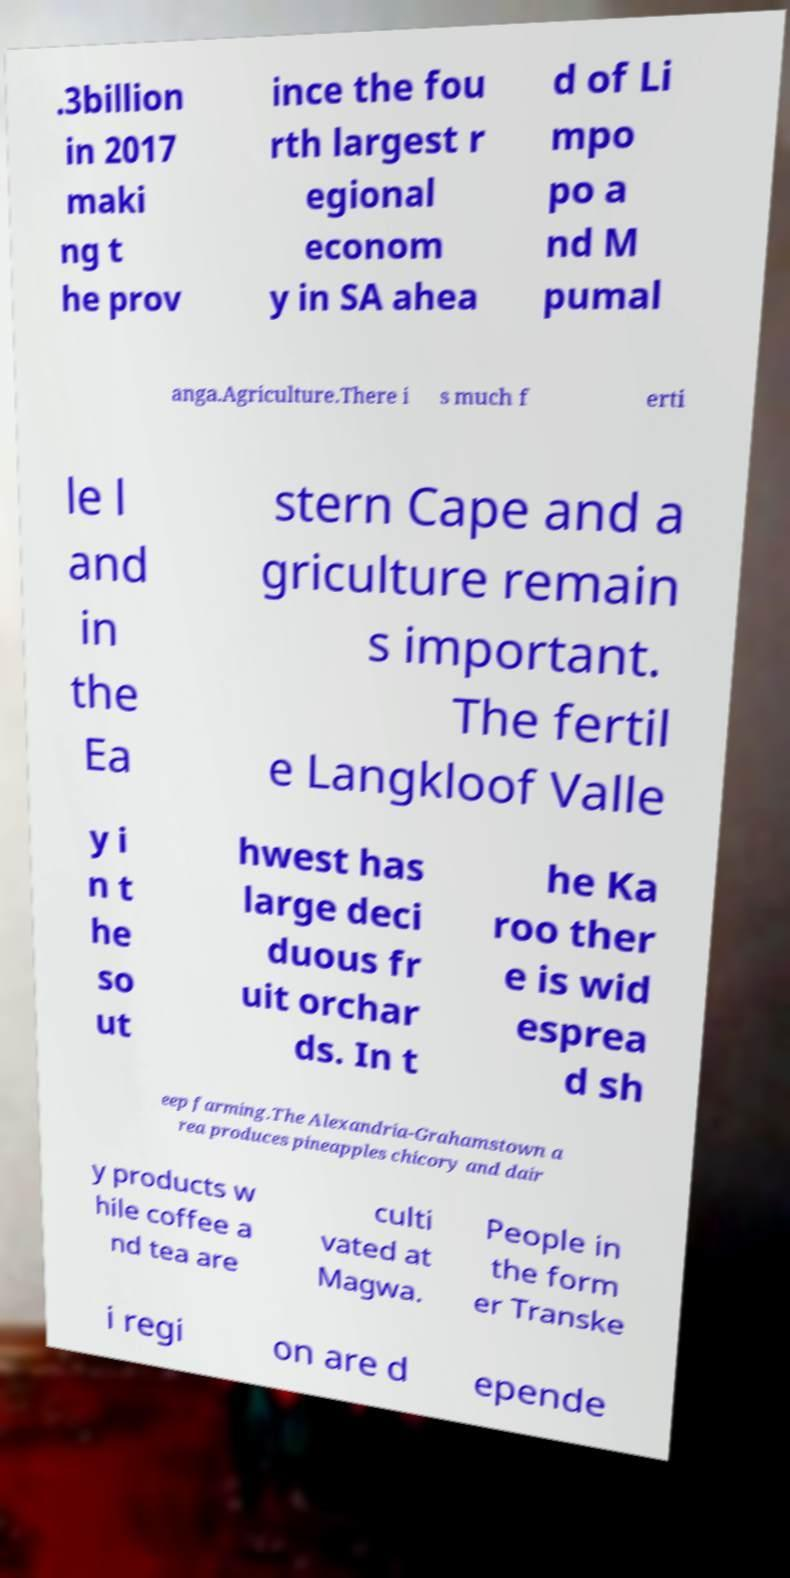Can you read and provide the text displayed in the image?This photo seems to have some interesting text. Can you extract and type it out for me? .3billion in 2017 maki ng t he prov ince the fou rth largest r egional econom y in SA ahea d of Li mpo po a nd M pumal anga.Agriculture.There i s much f erti le l and in the Ea stern Cape and a griculture remain s important. The fertil e Langkloof Valle y i n t he so ut hwest has large deci duous fr uit orchar ds. In t he Ka roo ther e is wid esprea d sh eep farming.The Alexandria-Grahamstown a rea produces pineapples chicory and dair y products w hile coffee a nd tea are culti vated at Magwa. People in the form er Transke i regi on are d epende 